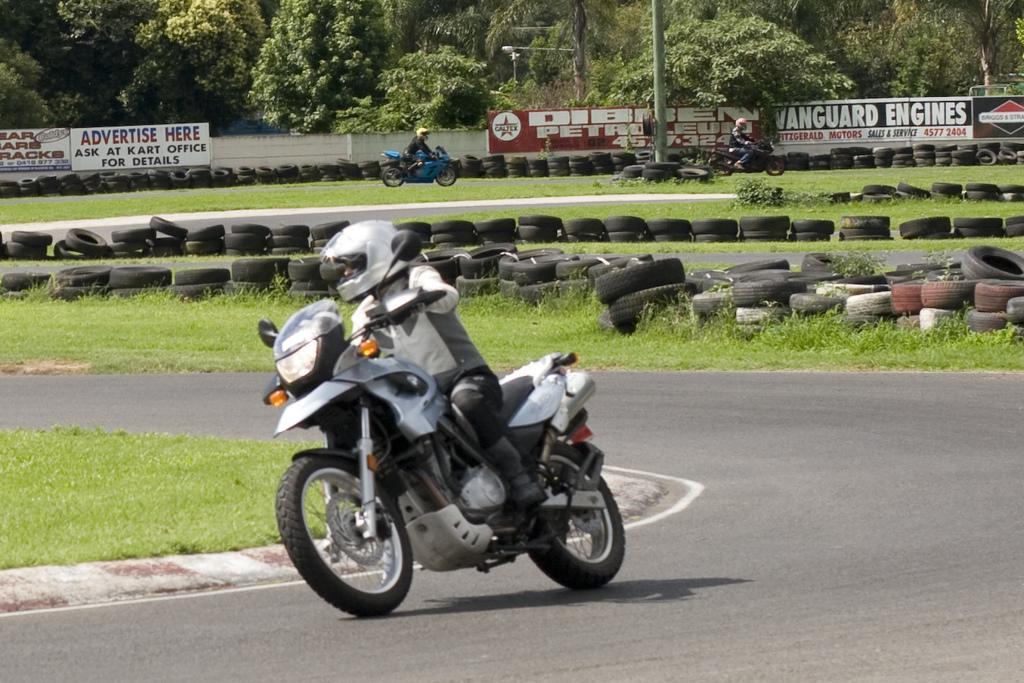Could you give a brief overview of what you see in this image? In the image there are few people riding bikes and they kept helmets on their heads. There are tires and grass on the ground. And also there is a road. In the background there is a wall with posters. Behind the wall there are trees and also there is a pole. 